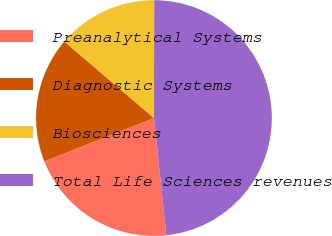<chart> <loc_0><loc_0><loc_500><loc_500><pie_chart><fcel>Preanalytical Systems<fcel>Diagnostic Systems<fcel>Biosciences<fcel>Total Life Sciences revenues<nl><fcel>20.69%<fcel>17.24%<fcel>13.79%<fcel>48.28%<nl></chart> 